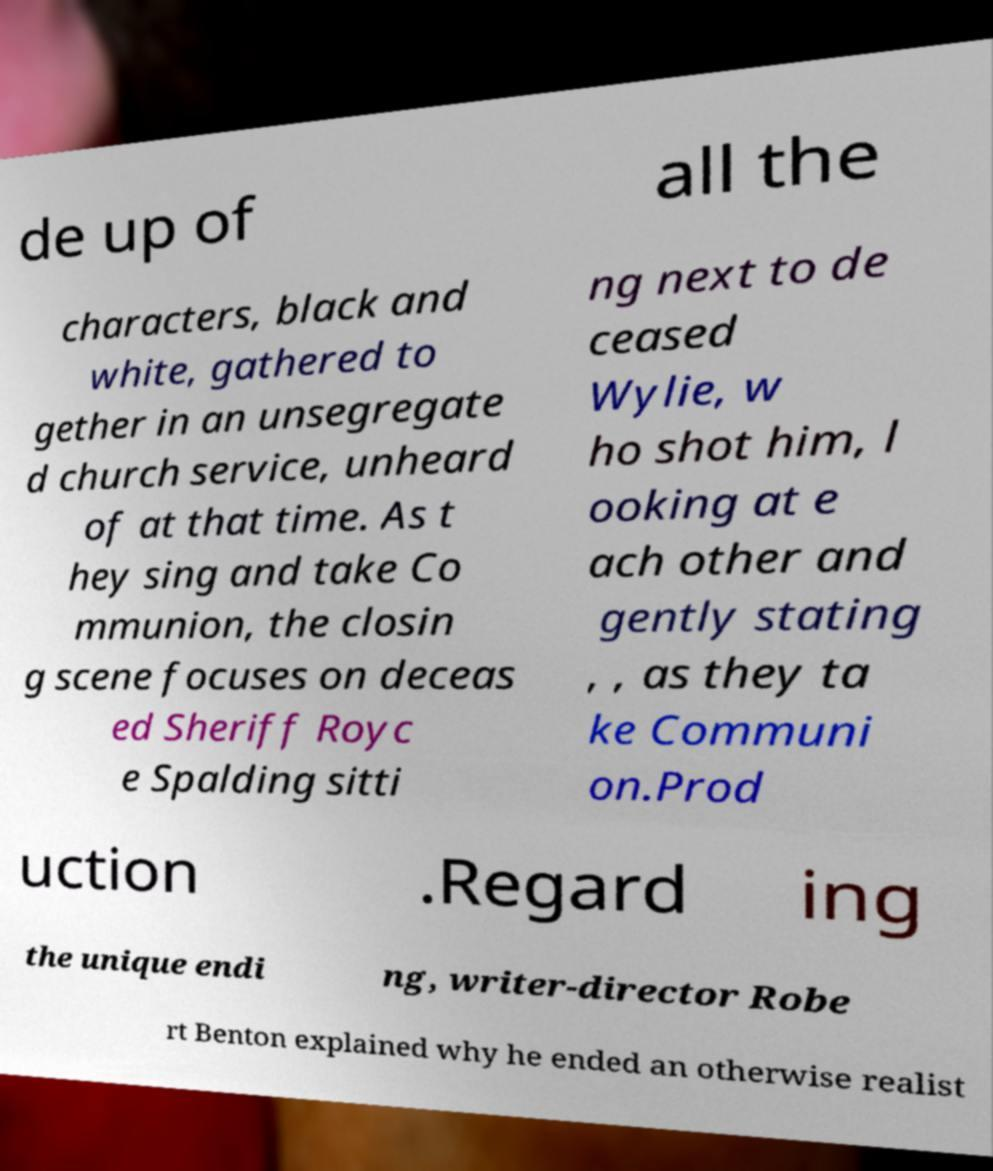Could you extract and type out the text from this image? de up of all the characters, black and white, gathered to gether in an unsegregate d church service, unheard of at that time. As t hey sing and take Co mmunion, the closin g scene focuses on deceas ed Sheriff Royc e Spalding sitti ng next to de ceased Wylie, w ho shot him, l ooking at e ach other and gently stating , , as they ta ke Communi on.Prod uction .Regard ing the unique endi ng, writer-director Robe rt Benton explained why he ended an otherwise realist 